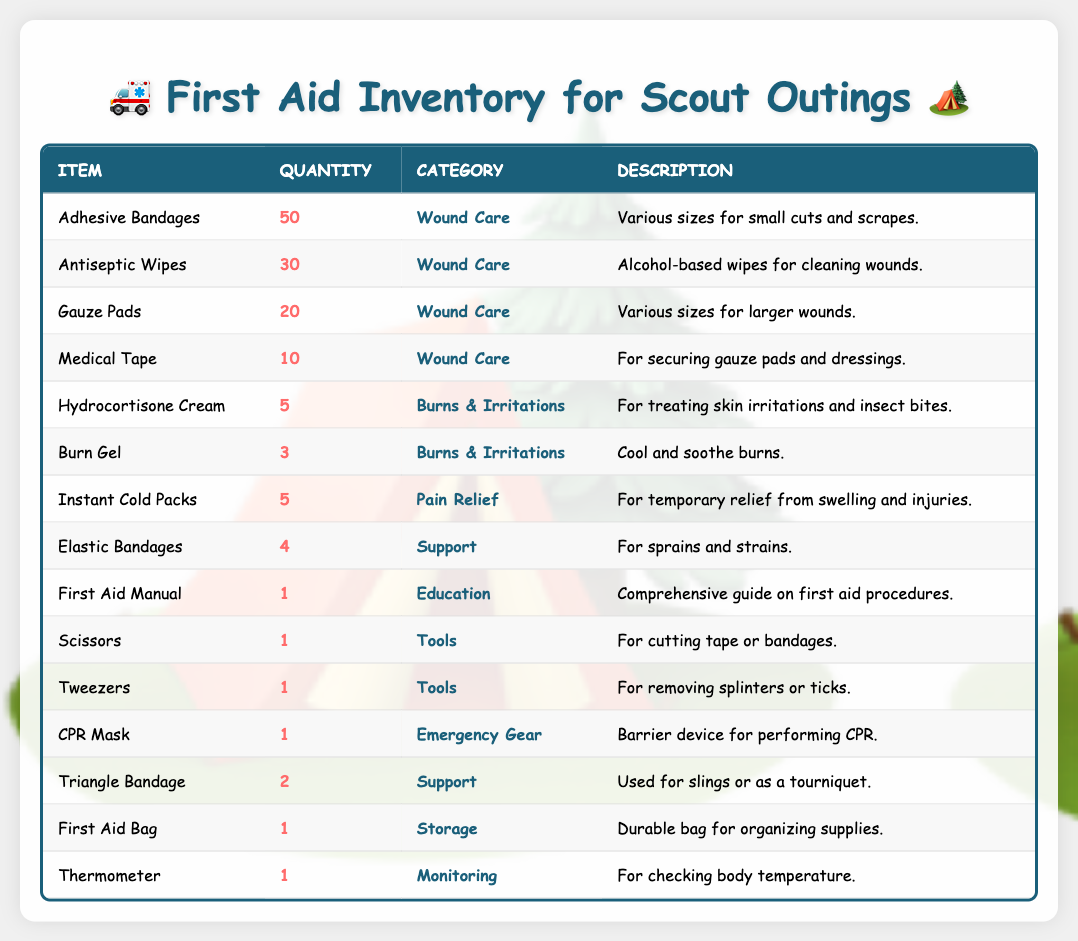What is the total number of Adhesive Bandages available? The quantity of Adhesive Bandages listed in the table is 50.
Answer: 50 How many different items are listed in the first aid supplies inventory? There are 15 unique items mentioned in the table.
Answer: 15 What category do the Instant Cold Packs belong to? Instant Cold Packs are classified under the Pain Relief category in the table.
Answer: Pain Relief How many Gauze Pads do we have in comparison to Burn Gel? The table shows 20 Gauze Pads and 3 Burn Gels. The difference is 20 - 3 = 17.
Answer: 17 Is there any item listed in the inventory that has a quantity of 0? There are no items with a quantity of 0 listed in the inventory.
Answer: No What is the total quantity of Wound Care supplies? The Wound Care category has Adhesive Bandages (50), Antiseptic Wipes (30), Gauze Pads (20), and Medical Tape (10). Summing these gives 50 + 30 + 20 + 10 = 110.
Answer: 110 Which category has the least number of supplies? The category with the least number of supplies is Burns & Irritations, with only 3 items (Burn Gel).
Answer: Burns & Irritations How many more Antiseptic Wipes than Hydrocortisone Cream are there? There are 30 Antiseptic Wipes and 5 Hydrocortisone Creams. The difference is 30 - 5 = 25.
Answer: 25 What item requires tools for its usage? Scissors and Tweezers are both items that require tools for their intended use.
Answer: Scissors and Tweezers What is the average quantity of supplies in the Monitoring and Emergency Gear categories? The Monitoring category has 1 (Thermometer) and Emergency Gear has 1 (CPR Mask). The average is (1 + 1) / 2 = 1.
Answer: 1 